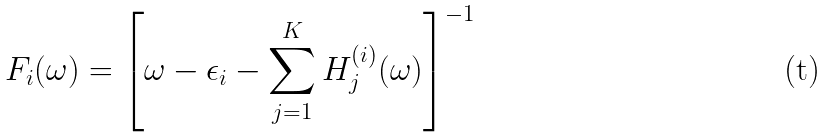<formula> <loc_0><loc_0><loc_500><loc_500>F _ { i } ( \omega ) = \left [ \omega - \epsilon _ { i } - \sum _ { j = 1 } ^ { K } H ^ { ( i ) } _ { j } ( \omega ) \right ] ^ { - 1 }</formula> 